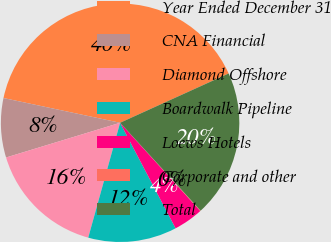<chart> <loc_0><loc_0><loc_500><loc_500><pie_chart><fcel>Year Ended December 31<fcel>CNA Financial<fcel>Diamond Offshore<fcel>Boardwalk Pipeline<fcel>Loews Hotels<fcel>Corporate and other<fcel>Total<nl><fcel>39.89%<fcel>8.03%<fcel>15.99%<fcel>12.01%<fcel>4.04%<fcel>0.06%<fcel>19.98%<nl></chart> 